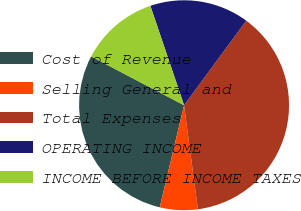<chart> <loc_0><loc_0><loc_500><loc_500><pie_chart><fcel>Cost of Revenue<fcel>Selling General and<fcel>Total Expenses<fcel>OPERATING INCOME<fcel>INCOME BEFORE INCOME TAXES<nl><fcel>28.97%<fcel>5.83%<fcel>37.81%<fcel>15.29%<fcel>12.1%<nl></chart> 